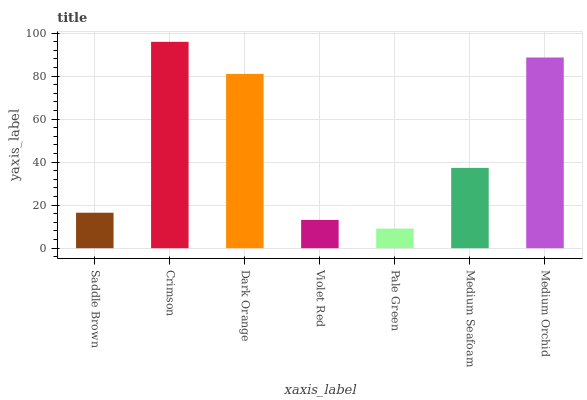Is Pale Green the minimum?
Answer yes or no. Yes. Is Crimson the maximum?
Answer yes or no. Yes. Is Dark Orange the minimum?
Answer yes or no. No. Is Dark Orange the maximum?
Answer yes or no. No. Is Crimson greater than Dark Orange?
Answer yes or no. Yes. Is Dark Orange less than Crimson?
Answer yes or no. Yes. Is Dark Orange greater than Crimson?
Answer yes or no. No. Is Crimson less than Dark Orange?
Answer yes or no. No. Is Medium Seafoam the high median?
Answer yes or no. Yes. Is Medium Seafoam the low median?
Answer yes or no. Yes. Is Crimson the high median?
Answer yes or no. No. Is Pale Green the low median?
Answer yes or no. No. 